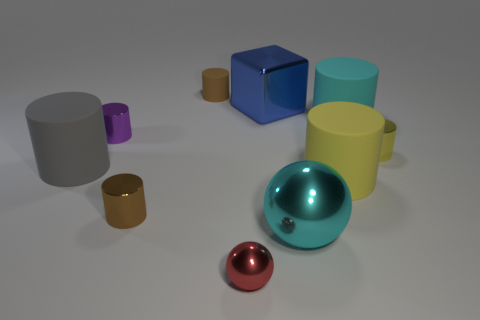Subtract all large cyan rubber cylinders. How many cylinders are left? 6 Subtract 2 spheres. How many spheres are left? 0 Subtract all brown blocks. How many yellow cylinders are left? 2 Subtract all cyan cylinders. How many cylinders are left? 6 Subtract all balls. How many objects are left? 8 Add 8 tiny spheres. How many tiny spheres are left? 9 Add 10 large green spheres. How many large green spheres exist? 10 Subtract 1 cyan spheres. How many objects are left? 9 Subtract all blue cylinders. Subtract all red blocks. How many cylinders are left? 7 Subtract all large cyan objects. Subtract all yellow cylinders. How many objects are left? 6 